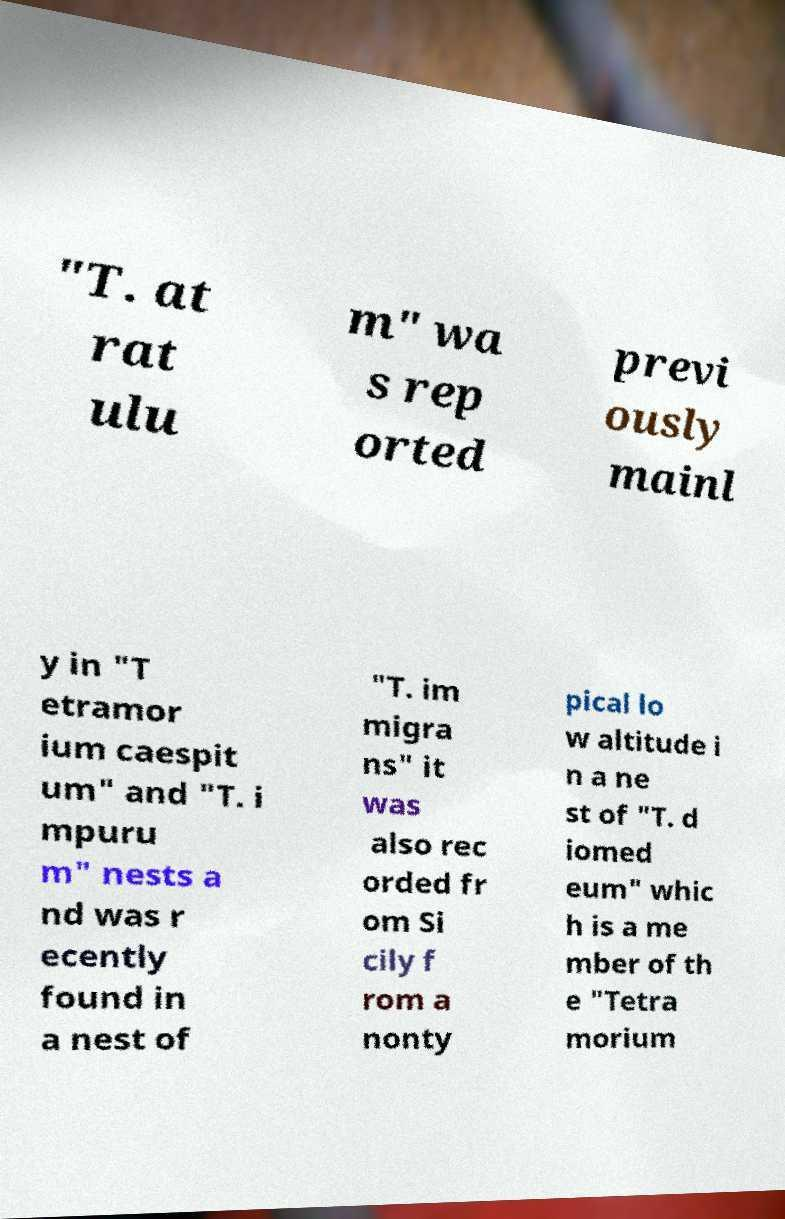What messages or text are displayed in this image? I need them in a readable, typed format. "T. at rat ulu m" wa s rep orted previ ously mainl y in "T etramor ium caespit um" and "T. i mpuru m" nests a nd was r ecently found in a nest of "T. im migra ns" it was also rec orded fr om Si cily f rom a nonty pical lo w altitude i n a ne st of "T. d iomed eum" whic h is a me mber of th e "Tetra morium 